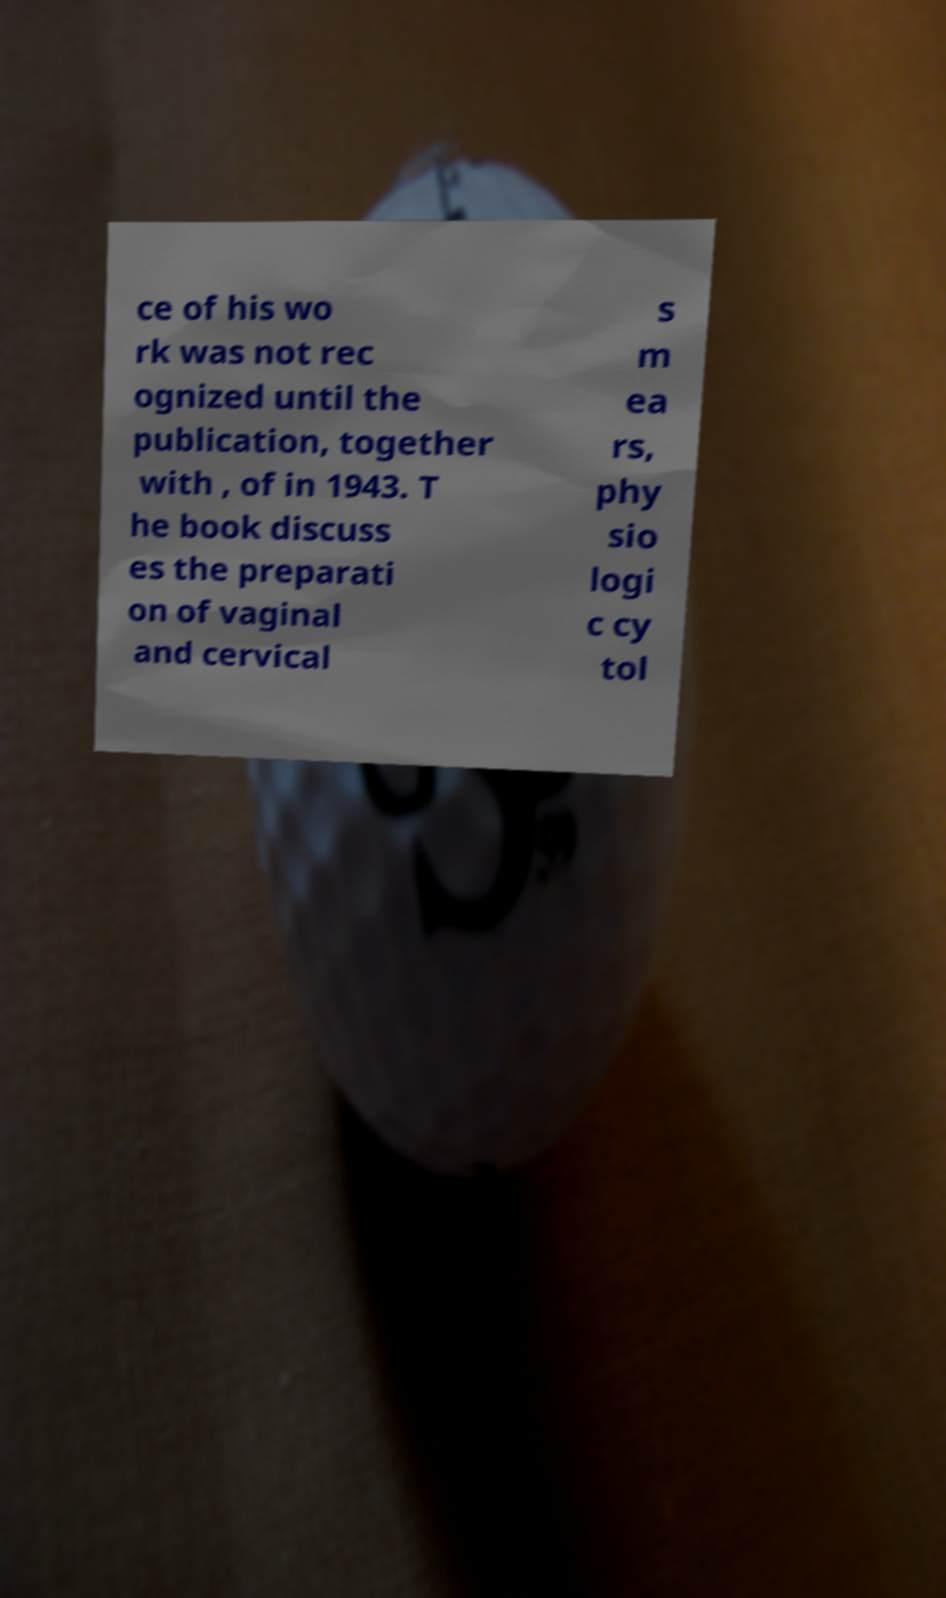Please read and relay the text visible in this image. What does it say? ce of his wo rk was not rec ognized until the publication, together with , of in 1943. T he book discuss es the preparati on of vaginal and cervical s m ea rs, phy sio logi c cy tol 